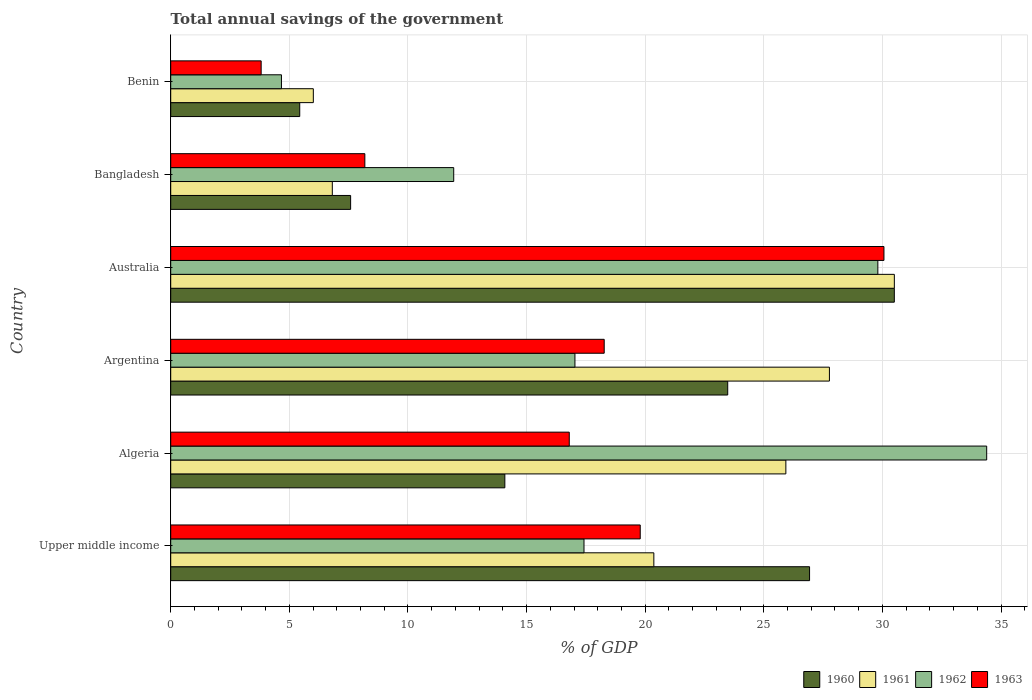How many groups of bars are there?
Keep it short and to the point. 6. What is the label of the 3rd group of bars from the top?
Make the answer very short. Australia. What is the total annual savings of the government in 1962 in Argentina?
Keep it short and to the point. 17.04. Across all countries, what is the maximum total annual savings of the government in 1961?
Your answer should be compact. 30.5. Across all countries, what is the minimum total annual savings of the government in 1963?
Your answer should be very brief. 3.81. In which country was the total annual savings of the government in 1962 maximum?
Provide a short and direct response. Algeria. In which country was the total annual savings of the government in 1961 minimum?
Keep it short and to the point. Benin. What is the total total annual savings of the government in 1961 in the graph?
Offer a terse response. 117.39. What is the difference between the total annual savings of the government in 1961 in Argentina and that in Australia?
Your answer should be very brief. -2.74. What is the difference between the total annual savings of the government in 1963 in Bangladesh and the total annual savings of the government in 1960 in Algeria?
Offer a terse response. -5.9. What is the average total annual savings of the government in 1961 per country?
Make the answer very short. 19.56. What is the difference between the total annual savings of the government in 1960 and total annual savings of the government in 1962 in Algeria?
Your answer should be very brief. -20.31. What is the ratio of the total annual savings of the government in 1963 in Australia to that in Benin?
Your response must be concise. 7.89. Is the difference between the total annual savings of the government in 1960 in Algeria and Australia greater than the difference between the total annual savings of the government in 1962 in Algeria and Australia?
Keep it short and to the point. No. What is the difference between the highest and the second highest total annual savings of the government in 1963?
Ensure brevity in your answer.  10.27. What is the difference between the highest and the lowest total annual savings of the government in 1960?
Make the answer very short. 25.06. Is it the case that in every country, the sum of the total annual savings of the government in 1963 and total annual savings of the government in 1960 is greater than the sum of total annual savings of the government in 1961 and total annual savings of the government in 1962?
Your answer should be compact. No. What does the 2nd bar from the top in Algeria represents?
Give a very brief answer. 1962. Is it the case that in every country, the sum of the total annual savings of the government in 1961 and total annual savings of the government in 1960 is greater than the total annual savings of the government in 1962?
Provide a succinct answer. Yes. How many bars are there?
Ensure brevity in your answer.  24. How many countries are there in the graph?
Make the answer very short. 6. Are the values on the major ticks of X-axis written in scientific E-notation?
Give a very brief answer. No. What is the title of the graph?
Your answer should be very brief. Total annual savings of the government. Does "2004" appear as one of the legend labels in the graph?
Provide a short and direct response. No. What is the label or title of the X-axis?
Make the answer very short. % of GDP. What is the % of GDP in 1960 in Upper middle income?
Make the answer very short. 26.93. What is the % of GDP in 1961 in Upper middle income?
Provide a short and direct response. 20.37. What is the % of GDP in 1962 in Upper middle income?
Your answer should be compact. 17.42. What is the % of GDP of 1963 in Upper middle income?
Your answer should be very brief. 19.79. What is the % of GDP of 1960 in Algeria?
Your answer should be compact. 14.08. What is the % of GDP in 1961 in Algeria?
Keep it short and to the point. 25.93. What is the % of GDP of 1962 in Algeria?
Provide a succinct answer. 34.4. What is the % of GDP of 1963 in Algeria?
Keep it short and to the point. 16.8. What is the % of GDP in 1960 in Argentina?
Offer a terse response. 23.48. What is the % of GDP in 1961 in Argentina?
Your answer should be very brief. 27.77. What is the % of GDP in 1962 in Argentina?
Offer a very short reply. 17.04. What is the % of GDP in 1963 in Argentina?
Offer a very short reply. 18.27. What is the % of GDP of 1960 in Australia?
Your answer should be compact. 30.5. What is the % of GDP of 1961 in Australia?
Your response must be concise. 30.5. What is the % of GDP of 1962 in Australia?
Offer a very short reply. 29.81. What is the % of GDP in 1963 in Australia?
Offer a terse response. 30.07. What is the % of GDP of 1960 in Bangladesh?
Offer a terse response. 7.58. What is the % of GDP of 1961 in Bangladesh?
Offer a very short reply. 6.81. What is the % of GDP in 1962 in Bangladesh?
Offer a terse response. 11.93. What is the % of GDP of 1963 in Bangladesh?
Keep it short and to the point. 8.18. What is the % of GDP in 1960 in Benin?
Provide a short and direct response. 5.44. What is the % of GDP of 1961 in Benin?
Provide a succinct answer. 6.01. What is the % of GDP of 1962 in Benin?
Give a very brief answer. 4.67. What is the % of GDP of 1963 in Benin?
Give a very brief answer. 3.81. Across all countries, what is the maximum % of GDP of 1960?
Your answer should be very brief. 30.5. Across all countries, what is the maximum % of GDP in 1961?
Ensure brevity in your answer.  30.5. Across all countries, what is the maximum % of GDP of 1962?
Offer a very short reply. 34.4. Across all countries, what is the maximum % of GDP in 1963?
Make the answer very short. 30.07. Across all countries, what is the minimum % of GDP of 1960?
Your answer should be very brief. 5.44. Across all countries, what is the minimum % of GDP in 1961?
Make the answer very short. 6.01. Across all countries, what is the minimum % of GDP of 1962?
Your answer should be compact. 4.67. Across all countries, what is the minimum % of GDP of 1963?
Provide a short and direct response. 3.81. What is the total % of GDP in 1960 in the graph?
Offer a terse response. 108.02. What is the total % of GDP in 1961 in the graph?
Your answer should be compact. 117.39. What is the total % of GDP of 1962 in the graph?
Keep it short and to the point. 115.26. What is the total % of GDP of 1963 in the graph?
Keep it short and to the point. 96.92. What is the difference between the % of GDP in 1960 in Upper middle income and that in Algeria?
Give a very brief answer. 12.84. What is the difference between the % of GDP in 1961 in Upper middle income and that in Algeria?
Make the answer very short. -5.57. What is the difference between the % of GDP of 1962 in Upper middle income and that in Algeria?
Offer a very short reply. -16.97. What is the difference between the % of GDP of 1963 in Upper middle income and that in Algeria?
Keep it short and to the point. 2.99. What is the difference between the % of GDP in 1960 in Upper middle income and that in Argentina?
Keep it short and to the point. 3.45. What is the difference between the % of GDP in 1961 in Upper middle income and that in Argentina?
Provide a short and direct response. -7.4. What is the difference between the % of GDP of 1962 in Upper middle income and that in Argentina?
Offer a very short reply. 0.38. What is the difference between the % of GDP of 1963 in Upper middle income and that in Argentina?
Keep it short and to the point. 1.52. What is the difference between the % of GDP in 1960 in Upper middle income and that in Australia?
Keep it short and to the point. -3.57. What is the difference between the % of GDP of 1961 in Upper middle income and that in Australia?
Provide a succinct answer. -10.14. What is the difference between the % of GDP of 1962 in Upper middle income and that in Australia?
Keep it short and to the point. -12.39. What is the difference between the % of GDP in 1963 in Upper middle income and that in Australia?
Provide a succinct answer. -10.27. What is the difference between the % of GDP in 1960 in Upper middle income and that in Bangladesh?
Offer a terse response. 19.35. What is the difference between the % of GDP in 1961 in Upper middle income and that in Bangladesh?
Offer a terse response. 13.55. What is the difference between the % of GDP of 1962 in Upper middle income and that in Bangladesh?
Offer a terse response. 5.49. What is the difference between the % of GDP in 1963 in Upper middle income and that in Bangladesh?
Provide a succinct answer. 11.61. What is the difference between the % of GDP of 1960 in Upper middle income and that in Benin?
Your answer should be very brief. 21.49. What is the difference between the % of GDP in 1961 in Upper middle income and that in Benin?
Your response must be concise. 14.35. What is the difference between the % of GDP in 1962 in Upper middle income and that in Benin?
Your answer should be compact. 12.75. What is the difference between the % of GDP in 1963 in Upper middle income and that in Benin?
Offer a terse response. 15.98. What is the difference between the % of GDP in 1960 in Algeria and that in Argentina?
Offer a terse response. -9.4. What is the difference between the % of GDP in 1961 in Algeria and that in Argentina?
Your answer should be compact. -1.84. What is the difference between the % of GDP of 1962 in Algeria and that in Argentina?
Offer a very short reply. 17.36. What is the difference between the % of GDP of 1963 in Algeria and that in Argentina?
Your response must be concise. -1.47. What is the difference between the % of GDP of 1960 in Algeria and that in Australia?
Offer a terse response. -16.42. What is the difference between the % of GDP of 1961 in Algeria and that in Australia?
Your answer should be compact. -4.57. What is the difference between the % of GDP in 1962 in Algeria and that in Australia?
Your answer should be compact. 4.59. What is the difference between the % of GDP in 1963 in Algeria and that in Australia?
Ensure brevity in your answer.  -13.27. What is the difference between the % of GDP of 1960 in Algeria and that in Bangladesh?
Make the answer very short. 6.5. What is the difference between the % of GDP in 1961 in Algeria and that in Bangladesh?
Offer a very short reply. 19.12. What is the difference between the % of GDP in 1962 in Algeria and that in Bangladesh?
Your answer should be compact. 22.47. What is the difference between the % of GDP in 1963 in Algeria and that in Bangladesh?
Provide a short and direct response. 8.62. What is the difference between the % of GDP in 1960 in Algeria and that in Benin?
Your response must be concise. 8.65. What is the difference between the % of GDP in 1961 in Algeria and that in Benin?
Your response must be concise. 19.92. What is the difference between the % of GDP in 1962 in Algeria and that in Benin?
Ensure brevity in your answer.  29.73. What is the difference between the % of GDP in 1963 in Algeria and that in Benin?
Keep it short and to the point. 12.99. What is the difference between the % of GDP of 1960 in Argentina and that in Australia?
Your response must be concise. -7.02. What is the difference between the % of GDP in 1961 in Argentina and that in Australia?
Your answer should be very brief. -2.74. What is the difference between the % of GDP of 1962 in Argentina and that in Australia?
Ensure brevity in your answer.  -12.77. What is the difference between the % of GDP of 1963 in Argentina and that in Australia?
Offer a very short reply. -11.79. What is the difference between the % of GDP of 1960 in Argentina and that in Bangladesh?
Your response must be concise. 15.9. What is the difference between the % of GDP in 1961 in Argentina and that in Bangladesh?
Offer a very short reply. 20.95. What is the difference between the % of GDP in 1962 in Argentina and that in Bangladesh?
Offer a very short reply. 5.11. What is the difference between the % of GDP in 1963 in Argentina and that in Bangladesh?
Provide a succinct answer. 10.09. What is the difference between the % of GDP in 1960 in Argentina and that in Benin?
Keep it short and to the point. 18.04. What is the difference between the % of GDP in 1961 in Argentina and that in Benin?
Provide a succinct answer. 21.75. What is the difference between the % of GDP in 1962 in Argentina and that in Benin?
Provide a succinct answer. 12.37. What is the difference between the % of GDP of 1963 in Argentina and that in Benin?
Offer a very short reply. 14.46. What is the difference between the % of GDP of 1960 in Australia and that in Bangladesh?
Your answer should be very brief. 22.92. What is the difference between the % of GDP of 1961 in Australia and that in Bangladesh?
Offer a terse response. 23.69. What is the difference between the % of GDP of 1962 in Australia and that in Bangladesh?
Make the answer very short. 17.88. What is the difference between the % of GDP of 1963 in Australia and that in Bangladesh?
Provide a succinct answer. 21.88. What is the difference between the % of GDP in 1960 in Australia and that in Benin?
Your answer should be compact. 25.06. What is the difference between the % of GDP in 1961 in Australia and that in Benin?
Offer a very short reply. 24.49. What is the difference between the % of GDP in 1962 in Australia and that in Benin?
Give a very brief answer. 25.14. What is the difference between the % of GDP of 1963 in Australia and that in Benin?
Your answer should be compact. 26.25. What is the difference between the % of GDP in 1960 in Bangladesh and that in Benin?
Keep it short and to the point. 2.15. What is the difference between the % of GDP of 1961 in Bangladesh and that in Benin?
Provide a succinct answer. 0.8. What is the difference between the % of GDP of 1962 in Bangladesh and that in Benin?
Ensure brevity in your answer.  7.26. What is the difference between the % of GDP of 1963 in Bangladesh and that in Benin?
Keep it short and to the point. 4.37. What is the difference between the % of GDP in 1960 in Upper middle income and the % of GDP in 1961 in Algeria?
Make the answer very short. 1. What is the difference between the % of GDP of 1960 in Upper middle income and the % of GDP of 1962 in Algeria?
Provide a succinct answer. -7.47. What is the difference between the % of GDP of 1960 in Upper middle income and the % of GDP of 1963 in Algeria?
Provide a short and direct response. 10.13. What is the difference between the % of GDP in 1961 in Upper middle income and the % of GDP in 1962 in Algeria?
Offer a terse response. -14.03. What is the difference between the % of GDP in 1961 in Upper middle income and the % of GDP in 1963 in Algeria?
Provide a succinct answer. 3.57. What is the difference between the % of GDP in 1962 in Upper middle income and the % of GDP in 1963 in Algeria?
Provide a short and direct response. 0.62. What is the difference between the % of GDP in 1960 in Upper middle income and the % of GDP in 1961 in Argentina?
Offer a very short reply. -0.84. What is the difference between the % of GDP in 1960 in Upper middle income and the % of GDP in 1962 in Argentina?
Your answer should be compact. 9.89. What is the difference between the % of GDP in 1960 in Upper middle income and the % of GDP in 1963 in Argentina?
Provide a short and direct response. 8.66. What is the difference between the % of GDP in 1961 in Upper middle income and the % of GDP in 1962 in Argentina?
Give a very brief answer. 3.33. What is the difference between the % of GDP of 1961 in Upper middle income and the % of GDP of 1963 in Argentina?
Give a very brief answer. 2.09. What is the difference between the % of GDP in 1962 in Upper middle income and the % of GDP in 1963 in Argentina?
Ensure brevity in your answer.  -0.85. What is the difference between the % of GDP in 1960 in Upper middle income and the % of GDP in 1961 in Australia?
Provide a succinct answer. -3.57. What is the difference between the % of GDP of 1960 in Upper middle income and the % of GDP of 1962 in Australia?
Your response must be concise. -2.88. What is the difference between the % of GDP in 1960 in Upper middle income and the % of GDP in 1963 in Australia?
Your answer should be compact. -3.14. What is the difference between the % of GDP of 1961 in Upper middle income and the % of GDP of 1962 in Australia?
Give a very brief answer. -9.44. What is the difference between the % of GDP of 1961 in Upper middle income and the % of GDP of 1963 in Australia?
Make the answer very short. -9.7. What is the difference between the % of GDP in 1962 in Upper middle income and the % of GDP in 1963 in Australia?
Your answer should be very brief. -12.64. What is the difference between the % of GDP in 1960 in Upper middle income and the % of GDP in 1961 in Bangladesh?
Your answer should be compact. 20.12. What is the difference between the % of GDP of 1960 in Upper middle income and the % of GDP of 1962 in Bangladesh?
Offer a terse response. 15. What is the difference between the % of GDP in 1960 in Upper middle income and the % of GDP in 1963 in Bangladesh?
Your response must be concise. 18.75. What is the difference between the % of GDP of 1961 in Upper middle income and the % of GDP of 1962 in Bangladesh?
Your answer should be very brief. 8.44. What is the difference between the % of GDP in 1961 in Upper middle income and the % of GDP in 1963 in Bangladesh?
Keep it short and to the point. 12.18. What is the difference between the % of GDP in 1962 in Upper middle income and the % of GDP in 1963 in Bangladesh?
Ensure brevity in your answer.  9.24. What is the difference between the % of GDP of 1960 in Upper middle income and the % of GDP of 1961 in Benin?
Provide a short and direct response. 20.92. What is the difference between the % of GDP in 1960 in Upper middle income and the % of GDP in 1962 in Benin?
Provide a short and direct response. 22.26. What is the difference between the % of GDP in 1960 in Upper middle income and the % of GDP in 1963 in Benin?
Offer a very short reply. 23.12. What is the difference between the % of GDP of 1961 in Upper middle income and the % of GDP of 1962 in Benin?
Ensure brevity in your answer.  15.7. What is the difference between the % of GDP of 1961 in Upper middle income and the % of GDP of 1963 in Benin?
Make the answer very short. 16.55. What is the difference between the % of GDP of 1962 in Upper middle income and the % of GDP of 1963 in Benin?
Your response must be concise. 13.61. What is the difference between the % of GDP of 1960 in Algeria and the % of GDP of 1961 in Argentina?
Your answer should be very brief. -13.68. What is the difference between the % of GDP in 1960 in Algeria and the % of GDP in 1962 in Argentina?
Offer a very short reply. -2.96. What is the difference between the % of GDP of 1960 in Algeria and the % of GDP of 1963 in Argentina?
Your response must be concise. -4.19. What is the difference between the % of GDP in 1961 in Algeria and the % of GDP in 1962 in Argentina?
Offer a very short reply. 8.89. What is the difference between the % of GDP in 1961 in Algeria and the % of GDP in 1963 in Argentina?
Your answer should be compact. 7.66. What is the difference between the % of GDP in 1962 in Algeria and the % of GDP in 1963 in Argentina?
Your answer should be compact. 16.12. What is the difference between the % of GDP in 1960 in Algeria and the % of GDP in 1961 in Australia?
Provide a succinct answer. -16.42. What is the difference between the % of GDP of 1960 in Algeria and the % of GDP of 1962 in Australia?
Keep it short and to the point. -15.72. What is the difference between the % of GDP in 1960 in Algeria and the % of GDP in 1963 in Australia?
Keep it short and to the point. -15.98. What is the difference between the % of GDP in 1961 in Algeria and the % of GDP in 1962 in Australia?
Your answer should be very brief. -3.88. What is the difference between the % of GDP of 1961 in Algeria and the % of GDP of 1963 in Australia?
Offer a very short reply. -4.13. What is the difference between the % of GDP in 1962 in Algeria and the % of GDP in 1963 in Australia?
Give a very brief answer. 4.33. What is the difference between the % of GDP in 1960 in Algeria and the % of GDP in 1961 in Bangladesh?
Provide a short and direct response. 7.27. What is the difference between the % of GDP of 1960 in Algeria and the % of GDP of 1962 in Bangladesh?
Provide a short and direct response. 2.16. What is the difference between the % of GDP of 1960 in Algeria and the % of GDP of 1963 in Bangladesh?
Give a very brief answer. 5.9. What is the difference between the % of GDP in 1961 in Algeria and the % of GDP in 1962 in Bangladesh?
Your answer should be compact. 14. What is the difference between the % of GDP in 1961 in Algeria and the % of GDP in 1963 in Bangladesh?
Make the answer very short. 17.75. What is the difference between the % of GDP of 1962 in Algeria and the % of GDP of 1963 in Bangladesh?
Provide a short and direct response. 26.21. What is the difference between the % of GDP in 1960 in Algeria and the % of GDP in 1961 in Benin?
Ensure brevity in your answer.  8.07. What is the difference between the % of GDP of 1960 in Algeria and the % of GDP of 1962 in Benin?
Ensure brevity in your answer.  9.42. What is the difference between the % of GDP in 1960 in Algeria and the % of GDP in 1963 in Benin?
Offer a very short reply. 10.27. What is the difference between the % of GDP of 1961 in Algeria and the % of GDP of 1962 in Benin?
Offer a terse response. 21.26. What is the difference between the % of GDP in 1961 in Algeria and the % of GDP in 1963 in Benin?
Give a very brief answer. 22.12. What is the difference between the % of GDP in 1962 in Algeria and the % of GDP in 1963 in Benin?
Provide a succinct answer. 30.58. What is the difference between the % of GDP in 1960 in Argentina and the % of GDP in 1961 in Australia?
Provide a succinct answer. -7.02. What is the difference between the % of GDP of 1960 in Argentina and the % of GDP of 1962 in Australia?
Offer a terse response. -6.33. What is the difference between the % of GDP in 1960 in Argentina and the % of GDP in 1963 in Australia?
Give a very brief answer. -6.59. What is the difference between the % of GDP of 1961 in Argentina and the % of GDP of 1962 in Australia?
Make the answer very short. -2.04. What is the difference between the % of GDP in 1961 in Argentina and the % of GDP in 1963 in Australia?
Provide a short and direct response. -2.3. What is the difference between the % of GDP of 1962 in Argentina and the % of GDP of 1963 in Australia?
Offer a very short reply. -13.03. What is the difference between the % of GDP of 1960 in Argentina and the % of GDP of 1961 in Bangladesh?
Your answer should be compact. 16.67. What is the difference between the % of GDP in 1960 in Argentina and the % of GDP in 1962 in Bangladesh?
Provide a short and direct response. 11.55. What is the difference between the % of GDP of 1960 in Argentina and the % of GDP of 1963 in Bangladesh?
Give a very brief answer. 15.3. What is the difference between the % of GDP in 1961 in Argentina and the % of GDP in 1962 in Bangladesh?
Offer a very short reply. 15.84. What is the difference between the % of GDP of 1961 in Argentina and the % of GDP of 1963 in Bangladesh?
Your response must be concise. 19.58. What is the difference between the % of GDP of 1962 in Argentina and the % of GDP of 1963 in Bangladesh?
Your response must be concise. 8.86. What is the difference between the % of GDP in 1960 in Argentina and the % of GDP in 1961 in Benin?
Your response must be concise. 17.47. What is the difference between the % of GDP of 1960 in Argentina and the % of GDP of 1962 in Benin?
Provide a succinct answer. 18.81. What is the difference between the % of GDP in 1960 in Argentina and the % of GDP in 1963 in Benin?
Your answer should be very brief. 19.67. What is the difference between the % of GDP of 1961 in Argentina and the % of GDP of 1962 in Benin?
Your answer should be compact. 23.1. What is the difference between the % of GDP of 1961 in Argentina and the % of GDP of 1963 in Benin?
Keep it short and to the point. 23.95. What is the difference between the % of GDP of 1962 in Argentina and the % of GDP of 1963 in Benin?
Provide a succinct answer. 13.23. What is the difference between the % of GDP in 1960 in Australia and the % of GDP in 1961 in Bangladesh?
Keep it short and to the point. 23.69. What is the difference between the % of GDP in 1960 in Australia and the % of GDP in 1962 in Bangladesh?
Offer a very short reply. 18.57. What is the difference between the % of GDP of 1960 in Australia and the % of GDP of 1963 in Bangladesh?
Offer a terse response. 22.32. What is the difference between the % of GDP in 1961 in Australia and the % of GDP in 1962 in Bangladesh?
Keep it short and to the point. 18.57. What is the difference between the % of GDP of 1961 in Australia and the % of GDP of 1963 in Bangladesh?
Make the answer very short. 22.32. What is the difference between the % of GDP of 1962 in Australia and the % of GDP of 1963 in Bangladesh?
Offer a very short reply. 21.62. What is the difference between the % of GDP of 1960 in Australia and the % of GDP of 1961 in Benin?
Offer a terse response. 24.49. What is the difference between the % of GDP in 1960 in Australia and the % of GDP in 1962 in Benin?
Provide a succinct answer. 25.83. What is the difference between the % of GDP in 1960 in Australia and the % of GDP in 1963 in Benin?
Offer a terse response. 26.69. What is the difference between the % of GDP of 1961 in Australia and the % of GDP of 1962 in Benin?
Your answer should be compact. 25.84. What is the difference between the % of GDP of 1961 in Australia and the % of GDP of 1963 in Benin?
Your answer should be very brief. 26.69. What is the difference between the % of GDP of 1962 in Australia and the % of GDP of 1963 in Benin?
Ensure brevity in your answer.  26. What is the difference between the % of GDP in 1960 in Bangladesh and the % of GDP in 1961 in Benin?
Your answer should be very brief. 1.57. What is the difference between the % of GDP of 1960 in Bangladesh and the % of GDP of 1962 in Benin?
Provide a succinct answer. 2.92. What is the difference between the % of GDP in 1960 in Bangladesh and the % of GDP in 1963 in Benin?
Your response must be concise. 3.77. What is the difference between the % of GDP of 1961 in Bangladesh and the % of GDP of 1962 in Benin?
Your answer should be compact. 2.14. What is the difference between the % of GDP in 1961 in Bangladesh and the % of GDP in 1963 in Benin?
Offer a very short reply. 3. What is the difference between the % of GDP of 1962 in Bangladesh and the % of GDP of 1963 in Benin?
Offer a terse response. 8.12. What is the average % of GDP in 1960 per country?
Your answer should be compact. 18. What is the average % of GDP of 1961 per country?
Ensure brevity in your answer.  19.56. What is the average % of GDP of 1962 per country?
Your answer should be compact. 19.21. What is the average % of GDP in 1963 per country?
Offer a terse response. 16.15. What is the difference between the % of GDP in 1960 and % of GDP in 1961 in Upper middle income?
Ensure brevity in your answer.  6.56. What is the difference between the % of GDP of 1960 and % of GDP of 1962 in Upper middle income?
Provide a succinct answer. 9.51. What is the difference between the % of GDP in 1960 and % of GDP in 1963 in Upper middle income?
Your answer should be very brief. 7.14. What is the difference between the % of GDP in 1961 and % of GDP in 1962 in Upper middle income?
Your answer should be compact. 2.94. What is the difference between the % of GDP of 1961 and % of GDP of 1963 in Upper middle income?
Ensure brevity in your answer.  0.57. What is the difference between the % of GDP in 1962 and % of GDP in 1963 in Upper middle income?
Keep it short and to the point. -2.37. What is the difference between the % of GDP of 1960 and % of GDP of 1961 in Algeria?
Your answer should be very brief. -11.85. What is the difference between the % of GDP of 1960 and % of GDP of 1962 in Algeria?
Give a very brief answer. -20.31. What is the difference between the % of GDP in 1960 and % of GDP in 1963 in Algeria?
Ensure brevity in your answer.  -2.72. What is the difference between the % of GDP in 1961 and % of GDP in 1962 in Algeria?
Keep it short and to the point. -8.47. What is the difference between the % of GDP in 1961 and % of GDP in 1963 in Algeria?
Give a very brief answer. 9.13. What is the difference between the % of GDP in 1962 and % of GDP in 1963 in Algeria?
Offer a very short reply. 17.6. What is the difference between the % of GDP of 1960 and % of GDP of 1961 in Argentina?
Keep it short and to the point. -4.29. What is the difference between the % of GDP of 1960 and % of GDP of 1962 in Argentina?
Offer a terse response. 6.44. What is the difference between the % of GDP in 1960 and % of GDP in 1963 in Argentina?
Offer a very short reply. 5.21. What is the difference between the % of GDP in 1961 and % of GDP in 1962 in Argentina?
Your answer should be very brief. 10.73. What is the difference between the % of GDP in 1961 and % of GDP in 1963 in Argentina?
Provide a short and direct response. 9.49. What is the difference between the % of GDP in 1962 and % of GDP in 1963 in Argentina?
Offer a very short reply. -1.23. What is the difference between the % of GDP in 1960 and % of GDP in 1961 in Australia?
Your answer should be very brief. -0. What is the difference between the % of GDP of 1960 and % of GDP of 1962 in Australia?
Your answer should be very brief. 0.7. What is the difference between the % of GDP of 1960 and % of GDP of 1963 in Australia?
Give a very brief answer. 0.44. What is the difference between the % of GDP of 1961 and % of GDP of 1962 in Australia?
Keep it short and to the point. 0.7. What is the difference between the % of GDP in 1961 and % of GDP in 1963 in Australia?
Offer a terse response. 0.44. What is the difference between the % of GDP in 1962 and % of GDP in 1963 in Australia?
Give a very brief answer. -0.26. What is the difference between the % of GDP of 1960 and % of GDP of 1961 in Bangladesh?
Your response must be concise. 0.77. What is the difference between the % of GDP of 1960 and % of GDP of 1962 in Bangladesh?
Ensure brevity in your answer.  -4.35. What is the difference between the % of GDP of 1960 and % of GDP of 1963 in Bangladesh?
Give a very brief answer. -0.6. What is the difference between the % of GDP of 1961 and % of GDP of 1962 in Bangladesh?
Your response must be concise. -5.12. What is the difference between the % of GDP of 1961 and % of GDP of 1963 in Bangladesh?
Offer a very short reply. -1.37. What is the difference between the % of GDP in 1962 and % of GDP in 1963 in Bangladesh?
Provide a succinct answer. 3.75. What is the difference between the % of GDP of 1960 and % of GDP of 1961 in Benin?
Keep it short and to the point. -0.57. What is the difference between the % of GDP in 1960 and % of GDP in 1962 in Benin?
Give a very brief answer. 0.77. What is the difference between the % of GDP in 1960 and % of GDP in 1963 in Benin?
Your response must be concise. 1.63. What is the difference between the % of GDP in 1961 and % of GDP in 1962 in Benin?
Your answer should be compact. 1.34. What is the difference between the % of GDP in 1961 and % of GDP in 1963 in Benin?
Ensure brevity in your answer.  2.2. What is the difference between the % of GDP of 1962 and % of GDP of 1963 in Benin?
Your response must be concise. 0.86. What is the ratio of the % of GDP in 1960 in Upper middle income to that in Algeria?
Your response must be concise. 1.91. What is the ratio of the % of GDP of 1961 in Upper middle income to that in Algeria?
Provide a short and direct response. 0.79. What is the ratio of the % of GDP of 1962 in Upper middle income to that in Algeria?
Make the answer very short. 0.51. What is the ratio of the % of GDP in 1963 in Upper middle income to that in Algeria?
Ensure brevity in your answer.  1.18. What is the ratio of the % of GDP in 1960 in Upper middle income to that in Argentina?
Ensure brevity in your answer.  1.15. What is the ratio of the % of GDP of 1961 in Upper middle income to that in Argentina?
Your response must be concise. 0.73. What is the ratio of the % of GDP in 1962 in Upper middle income to that in Argentina?
Give a very brief answer. 1.02. What is the ratio of the % of GDP in 1963 in Upper middle income to that in Argentina?
Provide a short and direct response. 1.08. What is the ratio of the % of GDP in 1960 in Upper middle income to that in Australia?
Provide a short and direct response. 0.88. What is the ratio of the % of GDP of 1961 in Upper middle income to that in Australia?
Provide a succinct answer. 0.67. What is the ratio of the % of GDP in 1962 in Upper middle income to that in Australia?
Offer a very short reply. 0.58. What is the ratio of the % of GDP in 1963 in Upper middle income to that in Australia?
Provide a short and direct response. 0.66. What is the ratio of the % of GDP in 1960 in Upper middle income to that in Bangladesh?
Keep it short and to the point. 3.55. What is the ratio of the % of GDP of 1961 in Upper middle income to that in Bangladesh?
Provide a succinct answer. 2.99. What is the ratio of the % of GDP in 1962 in Upper middle income to that in Bangladesh?
Ensure brevity in your answer.  1.46. What is the ratio of the % of GDP in 1963 in Upper middle income to that in Bangladesh?
Give a very brief answer. 2.42. What is the ratio of the % of GDP in 1960 in Upper middle income to that in Benin?
Make the answer very short. 4.95. What is the ratio of the % of GDP of 1961 in Upper middle income to that in Benin?
Give a very brief answer. 3.39. What is the ratio of the % of GDP in 1962 in Upper middle income to that in Benin?
Provide a succinct answer. 3.73. What is the ratio of the % of GDP of 1963 in Upper middle income to that in Benin?
Your answer should be very brief. 5.19. What is the ratio of the % of GDP in 1960 in Algeria to that in Argentina?
Provide a succinct answer. 0.6. What is the ratio of the % of GDP in 1961 in Algeria to that in Argentina?
Your answer should be compact. 0.93. What is the ratio of the % of GDP of 1962 in Algeria to that in Argentina?
Ensure brevity in your answer.  2.02. What is the ratio of the % of GDP of 1963 in Algeria to that in Argentina?
Your response must be concise. 0.92. What is the ratio of the % of GDP of 1960 in Algeria to that in Australia?
Provide a short and direct response. 0.46. What is the ratio of the % of GDP in 1961 in Algeria to that in Australia?
Ensure brevity in your answer.  0.85. What is the ratio of the % of GDP of 1962 in Algeria to that in Australia?
Provide a succinct answer. 1.15. What is the ratio of the % of GDP of 1963 in Algeria to that in Australia?
Your answer should be very brief. 0.56. What is the ratio of the % of GDP in 1960 in Algeria to that in Bangladesh?
Your response must be concise. 1.86. What is the ratio of the % of GDP in 1961 in Algeria to that in Bangladesh?
Your response must be concise. 3.81. What is the ratio of the % of GDP of 1962 in Algeria to that in Bangladesh?
Provide a succinct answer. 2.88. What is the ratio of the % of GDP in 1963 in Algeria to that in Bangladesh?
Your answer should be compact. 2.05. What is the ratio of the % of GDP of 1960 in Algeria to that in Benin?
Your answer should be compact. 2.59. What is the ratio of the % of GDP in 1961 in Algeria to that in Benin?
Keep it short and to the point. 4.31. What is the ratio of the % of GDP in 1962 in Algeria to that in Benin?
Provide a short and direct response. 7.37. What is the ratio of the % of GDP of 1963 in Algeria to that in Benin?
Provide a short and direct response. 4.41. What is the ratio of the % of GDP in 1960 in Argentina to that in Australia?
Give a very brief answer. 0.77. What is the ratio of the % of GDP of 1961 in Argentina to that in Australia?
Make the answer very short. 0.91. What is the ratio of the % of GDP in 1962 in Argentina to that in Australia?
Your answer should be compact. 0.57. What is the ratio of the % of GDP in 1963 in Argentina to that in Australia?
Your answer should be compact. 0.61. What is the ratio of the % of GDP in 1960 in Argentina to that in Bangladesh?
Your answer should be very brief. 3.1. What is the ratio of the % of GDP of 1961 in Argentina to that in Bangladesh?
Your response must be concise. 4.08. What is the ratio of the % of GDP in 1962 in Argentina to that in Bangladesh?
Ensure brevity in your answer.  1.43. What is the ratio of the % of GDP in 1963 in Argentina to that in Bangladesh?
Keep it short and to the point. 2.23. What is the ratio of the % of GDP in 1960 in Argentina to that in Benin?
Your answer should be very brief. 4.32. What is the ratio of the % of GDP of 1961 in Argentina to that in Benin?
Give a very brief answer. 4.62. What is the ratio of the % of GDP in 1962 in Argentina to that in Benin?
Your answer should be compact. 3.65. What is the ratio of the % of GDP in 1963 in Argentina to that in Benin?
Ensure brevity in your answer.  4.79. What is the ratio of the % of GDP in 1960 in Australia to that in Bangladesh?
Your answer should be compact. 4.02. What is the ratio of the % of GDP of 1961 in Australia to that in Bangladesh?
Keep it short and to the point. 4.48. What is the ratio of the % of GDP in 1962 in Australia to that in Bangladesh?
Make the answer very short. 2.5. What is the ratio of the % of GDP of 1963 in Australia to that in Bangladesh?
Offer a very short reply. 3.67. What is the ratio of the % of GDP of 1960 in Australia to that in Benin?
Provide a succinct answer. 5.61. What is the ratio of the % of GDP in 1961 in Australia to that in Benin?
Ensure brevity in your answer.  5.07. What is the ratio of the % of GDP in 1962 in Australia to that in Benin?
Your answer should be compact. 6.39. What is the ratio of the % of GDP of 1963 in Australia to that in Benin?
Ensure brevity in your answer.  7.89. What is the ratio of the % of GDP of 1960 in Bangladesh to that in Benin?
Give a very brief answer. 1.39. What is the ratio of the % of GDP in 1961 in Bangladesh to that in Benin?
Ensure brevity in your answer.  1.13. What is the ratio of the % of GDP in 1962 in Bangladesh to that in Benin?
Your response must be concise. 2.56. What is the ratio of the % of GDP of 1963 in Bangladesh to that in Benin?
Make the answer very short. 2.15. What is the difference between the highest and the second highest % of GDP in 1960?
Ensure brevity in your answer.  3.57. What is the difference between the highest and the second highest % of GDP of 1961?
Offer a very short reply. 2.74. What is the difference between the highest and the second highest % of GDP of 1962?
Provide a succinct answer. 4.59. What is the difference between the highest and the second highest % of GDP in 1963?
Make the answer very short. 10.27. What is the difference between the highest and the lowest % of GDP in 1960?
Give a very brief answer. 25.06. What is the difference between the highest and the lowest % of GDP in 1961?
Give a very brief answer. 24.49. What is the difference between the highest and the lowest % of GDP of 1962?
Give a very brief answer. 29.73. What is the difference between the highest and the lowest % of GDP of 1963?
Offer a terse response. 26.25. 